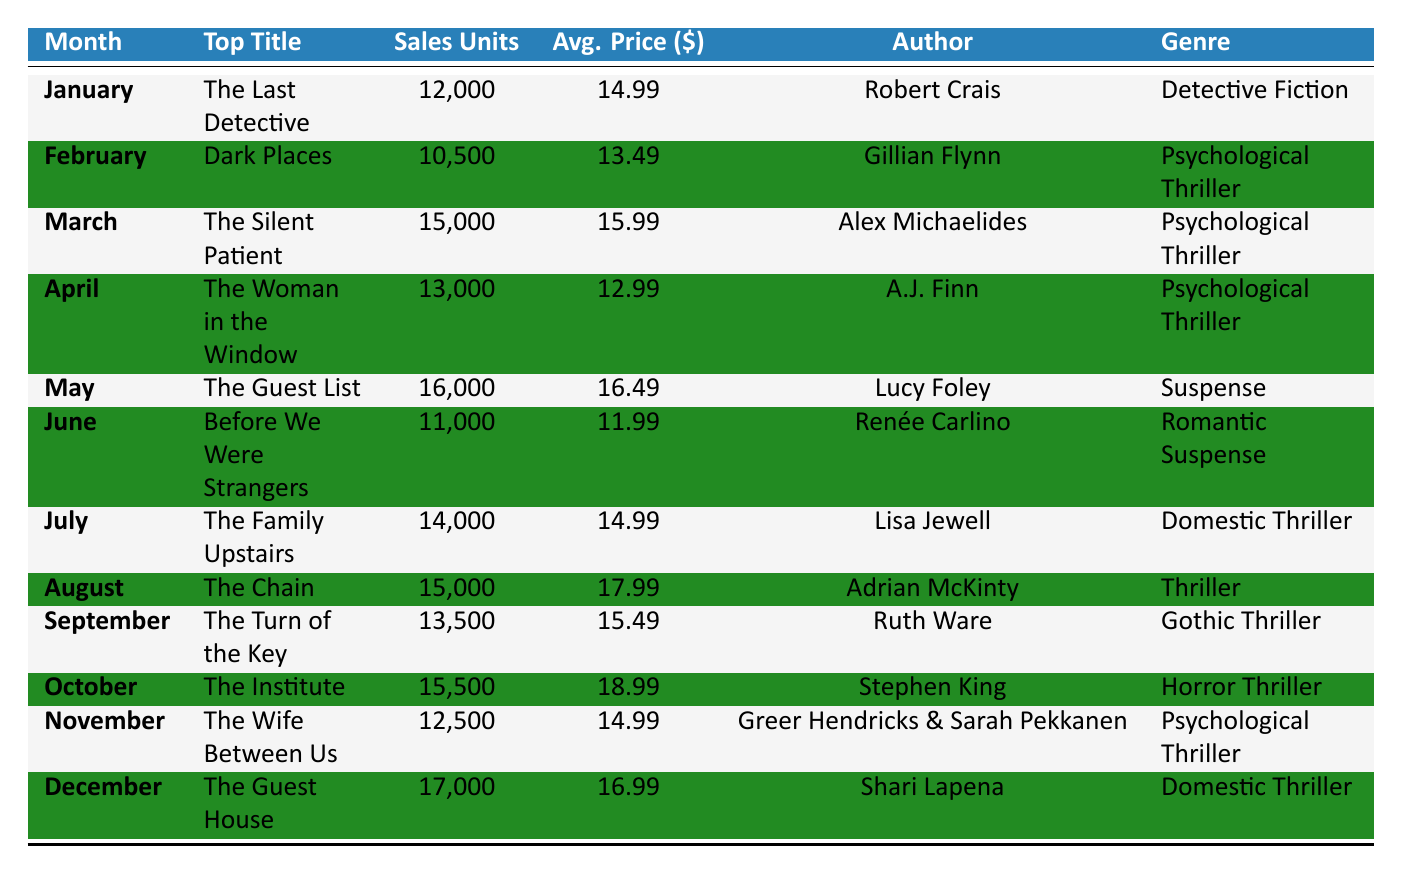What was the total number of sales units across all months? To find the total sales, sum the sales units from each month: 12000 + 10500 + 15000 + 13000 + 16000 + 11000 + 14000 + 15000 + 13500 + 15500 + 12500 + 17000 = 169000.
Answer: 169000 Which month had the highest average price for crime fiction? Review the average price column for each month: January (14.99), February (13.49), March (15.99), April (12.99), May (16.49), June (11.99), July (14.99), August (17.99), September (15.49), October (18.99), November (14.99), December (16.99). The highest average price is October with 18.99.
Answer: October Was "The Last Detective" the top title in March? Check the top title for March, which is "The Silent Patient." Therefore, "The Last Detective" was not the top title in March.
Answer: No How many sales units were sold in the months classified as Psychological Thriller? The corresponding months are February (10500), March (15000), April (13000), and November (12500). Total these units: 10500 + 15000 + 13000 + 12500 = 51000.
Answer: 51000 Which genre had the most units sold in December? The genre for December is Domestic Thriller, with 17000 sales units. By checking all months, identify the max sales for Domestic Thriller, which is 17000 in December.
Answer: Domestic Thriller How many months had sales units above 14000? Inspect the sales units: January (12000), February (10500), March (15000), April (13000), May (16000), June (11000), July (14000), August (15000), September (13500), October (15500), November (12500), December (17000). The months with more than 14000 are March, May, August, October, and December, totaling 5 months.
Answer: 5 What is the average sales units for the month with the lowest sales? The lowest sales units is in February with 10500. The average sales for this single month is 10500 itself since there's only one month.
Answer: 10500 Did the sales trend increase every month? Comparing each month's sales: January (12000), February (10500), March (15000), April (13000), May (16000), June (11000), July (14000), August (15000), September (13500), October (15500), November (12500), December (17000), we can see that the trend did not consistently increase due to declines in February and June.
Answer: No 